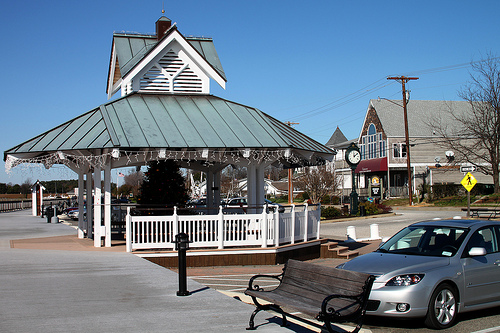Envision a fantasy scene occurring in this location and describe it in detail. In this fantasy scene, the gazebo transforms into a mystical portal. As the sun sets, its roof shimmers with magical energy, and ethereal creatures emerge—fairies with glowing wings, wise old owls with sparkling feathers, and gentle, colorful dragons that circle the sky. The boardwalk becomes a pathway lined with enchanted lanterns that light up on their own, guiding visitors to the portal. The trees whisper secrets from ancient times, and a melodic tune from an unseen harp fills the air, enchanting all who hear it. This gathering becomes a celebration of the unity between the magical and mortal worlds, where stories and legends come to life under a veil of starlight. 